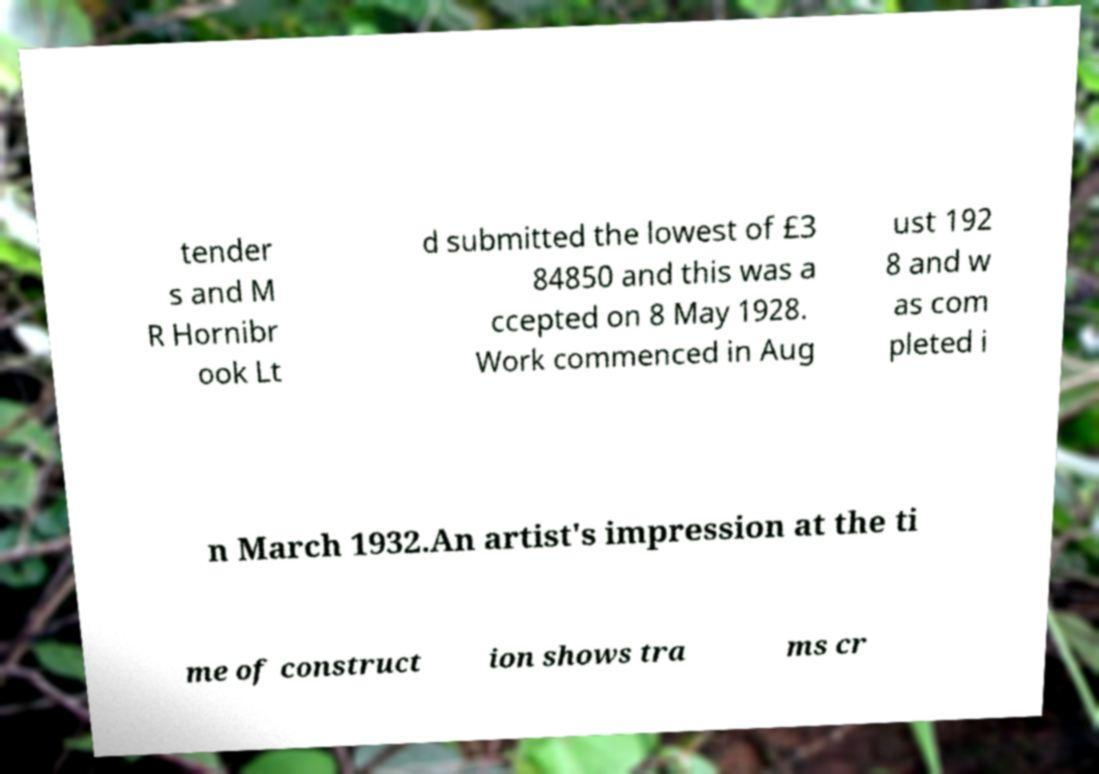For documentation purposes, I need the text within this image transcribed. Could you provide that? tender s and M R Hornibr ook Lt d submitted the lowest of £3 84850 and this was a ccepted on 8 May 1928. Work commenced in Aug ust 192 8 and w as com pleted i n March 1932.An artist's impression at the ti me of construct ion shows tra ms cr 